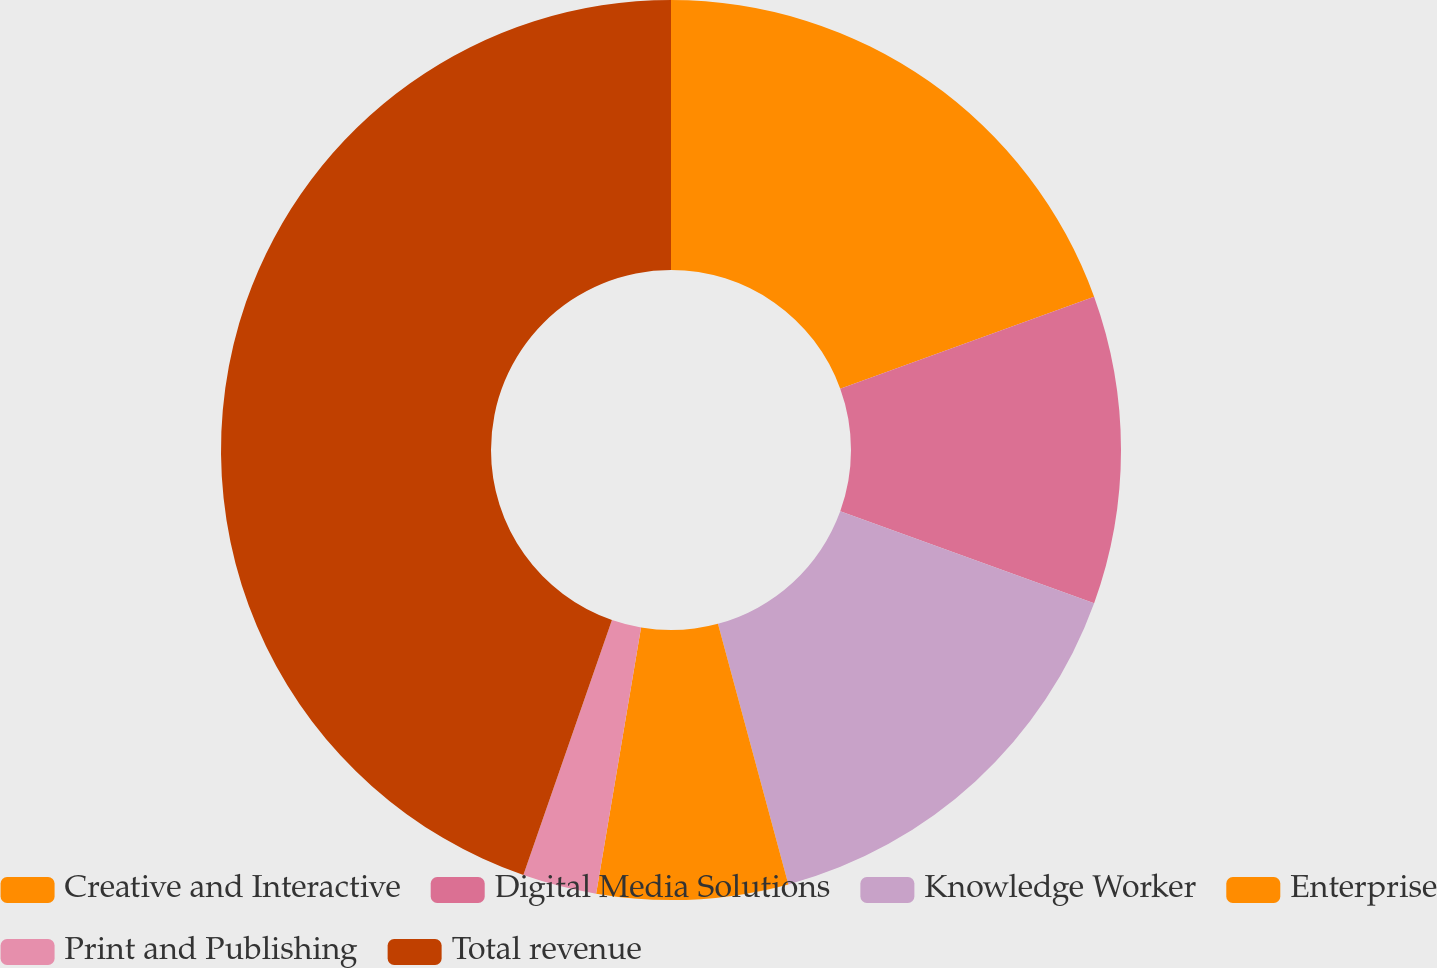Convert chart. <chart><loc_0><loc_0><loc_500><loc_500><pie_chart><fcel>Creative and Interactive<fcel>Digital Media Solutions<fcel>Knowledge Worker<fcel>Enterprise<fcel>Print and Publishing<fcel>Total revenue<nl><fcel>19.47%<fcel>11.06%<fcel>15.27%<fcel>6.86%<fcel>2.66%<fcel>44.68%<nl></chart> 